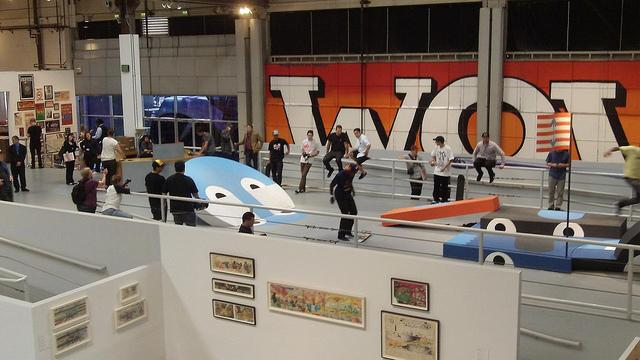How many pictures are there on the wall?
Short answer required. 10. What color is the wall in the foreground?
Keep it brief. White. Can you see a flag?
Short answer required. Yes. 